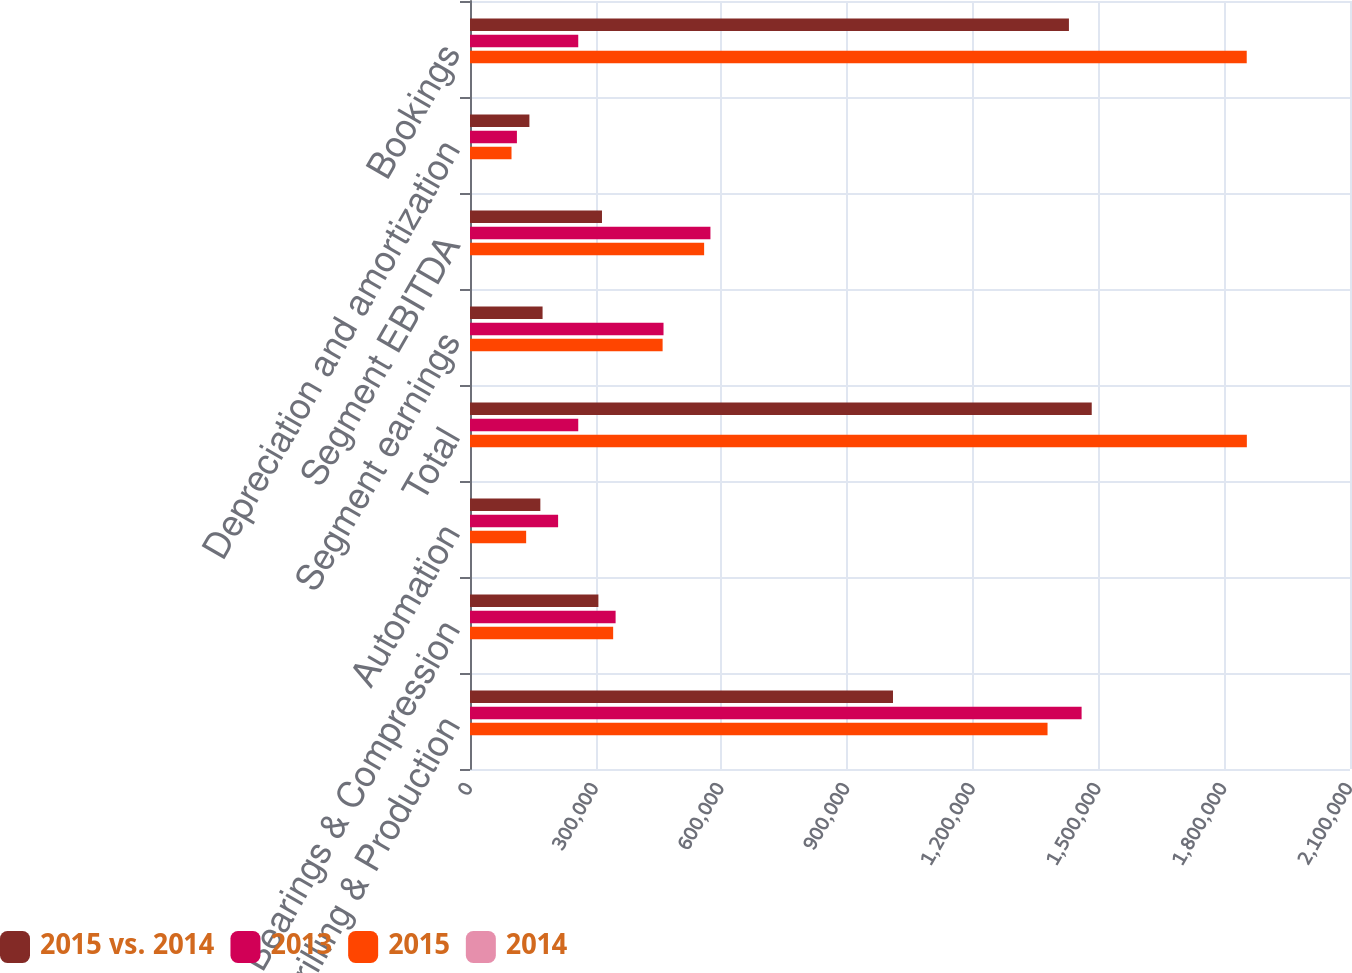<chart> <loc_0><loc_0><loc_500><loc_500><stacked_bar_chart><ecel><fcel>Drilling & Production<fcel>Bearings & Compression<fcel>Automation<fcel>Total<fcel>Segment earnings<fcel>Segment EBITDA<fcel>Depreciation and amortization<fcel>Bookings<nl><fcel>2015 vs. 2014<fcel>1.00942e+06<fcel>306387<fcel>167877<fcel>1.48368e+06<fcel>173190<fcel>314969<fcel>141779<fcel>1.42926e+06<nl><fcel>2013<fcel>1.45951e+06<fcel>347470<fcel>210255<fcel>258321<fcel>461815<fcel>573771<fcel>111956<fcel>258321<nl><fcel>2015<fcel>1.37822e+06<fcel>341628<fcel>134000<fcel>1.85385e+06<fcel>459649<fcel>558724<fcel>99075<fcel>1.85356e+06<nl><fcel>2014<fcel>30.8<fcel>11.8<fcel>20.2<fcel>26.4<fcel>62.5<fcel>45.1<fcel>26.6<fcel>29.1<nl></chart> 